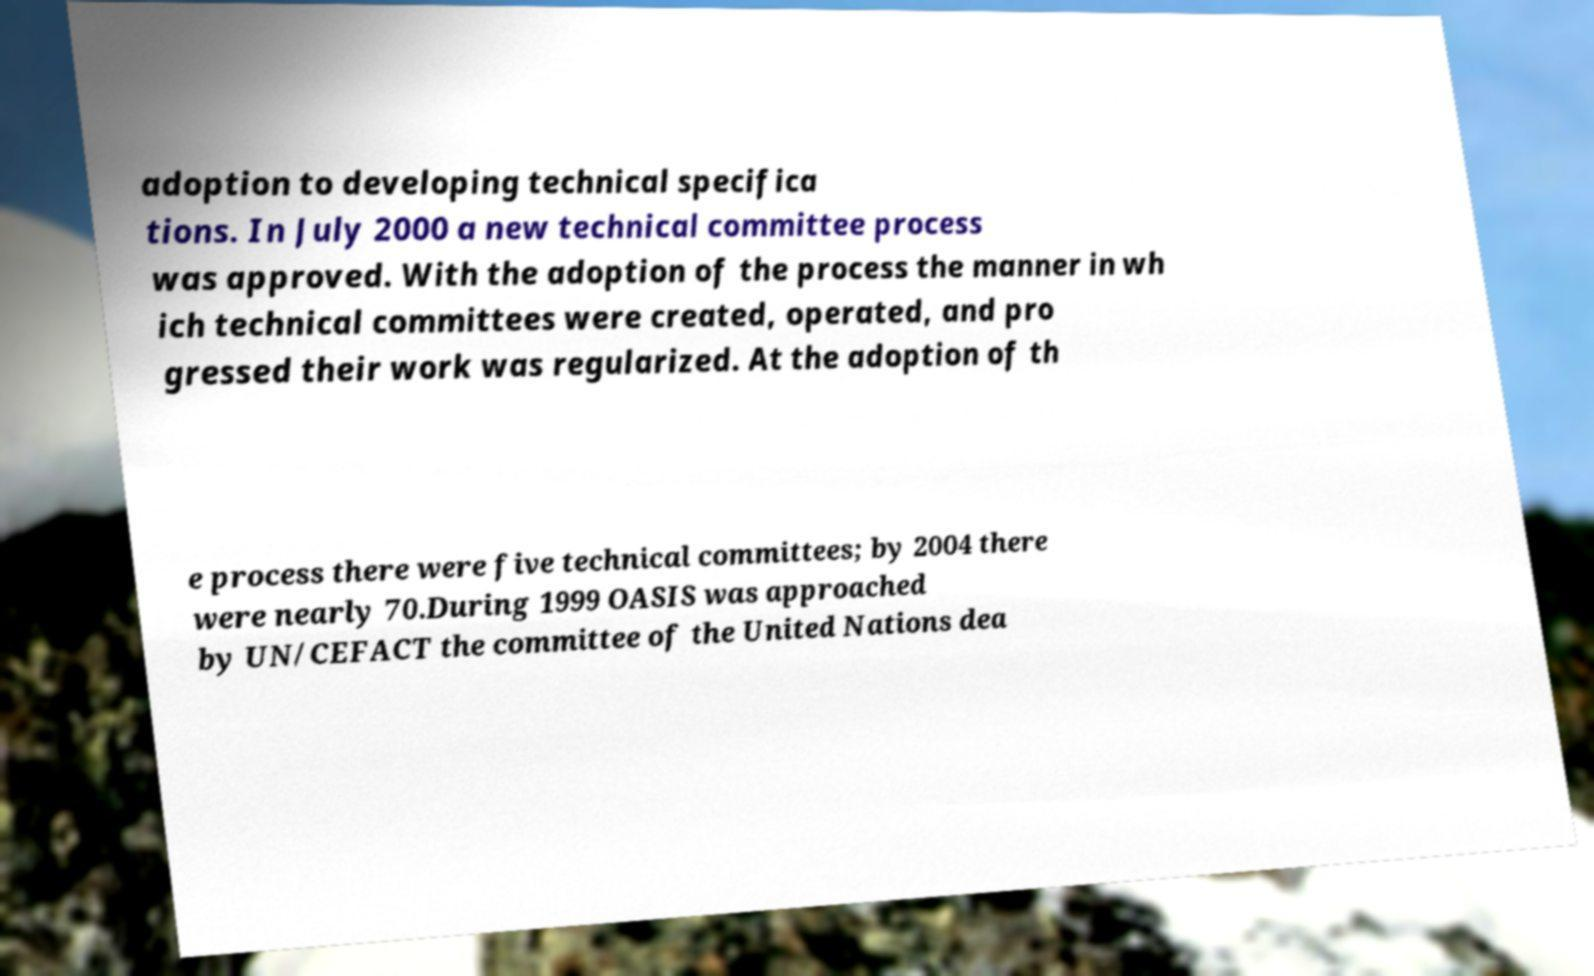For documentation purposes, I need the text within this image transcribed. Could you provide that? adoption to developing technical specifica tions. In July 2000 a new technical committee process was approved. With the adoption of the process the manner in wh ich technical committees were created, operated, and pro gressed their work was regularized. At the adoption of th e process there were five technical committees; by 2004 there were nearly 70.During 1999 OASIS was approached by UN/CEFACT the committee of the United Nations dea 